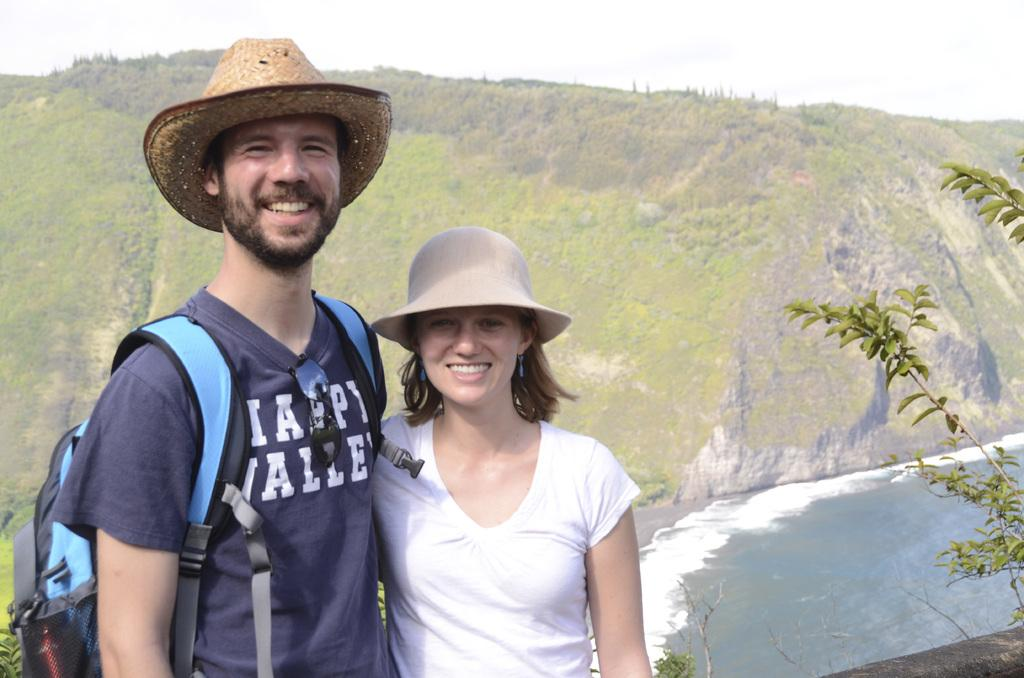<image>
Create a compact narrative representing the image presented. His shirt with white writing the bottom word says valley 